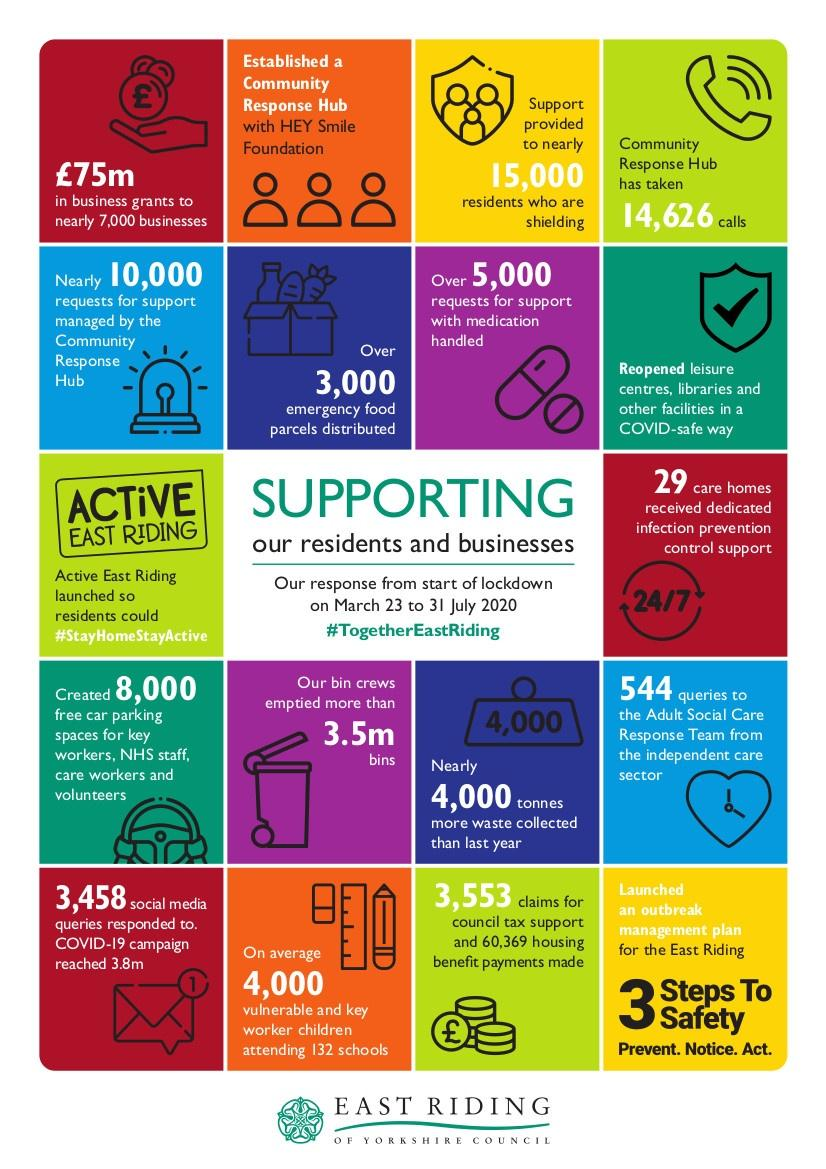Point out several critical features in this image. The East Riding of Yorkshire Council handled more than 5,000 requests for medication support during the period of March 23 to July 31, 2020. The value of business grants provided by the East Riding of Yorkshire Council from March 23 to July 31, 2020 amounted to 75 million pounds. The community response hub received 14,626 calls in total according to the survey. 